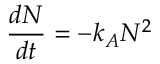Convert formula to latex. <formula><loc_0><loc_0><loc_500><loc_500>\frac { d N } { d t } = - k _ { A } N ^ { 2 }</formula> 